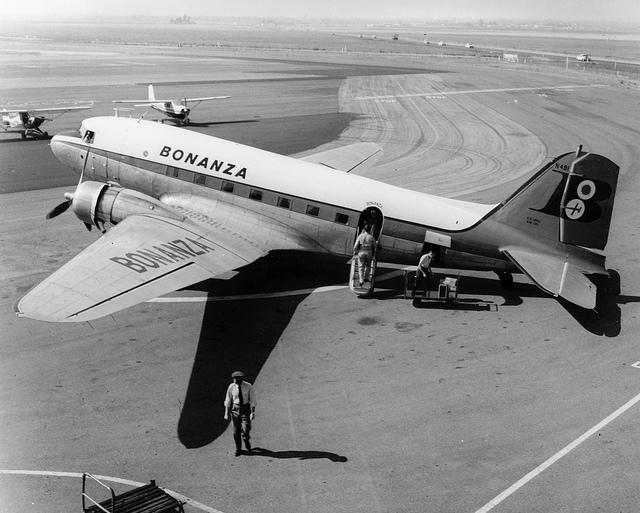Does this plane have propellers?
Write a very short answer. Yes. Is the planes landing gear down?
Quick response, please. Yes. What airline is this?
Short answer required. Bonanza. 